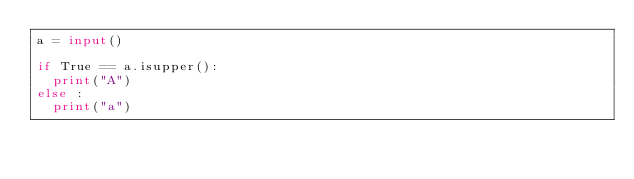Convert code to text. <code><loc_0><loc_0><loc_500><loc_500><_Python_>a = input()
 
if True == a.isupper():
  print("A")
else :
  print("a")
</code> 